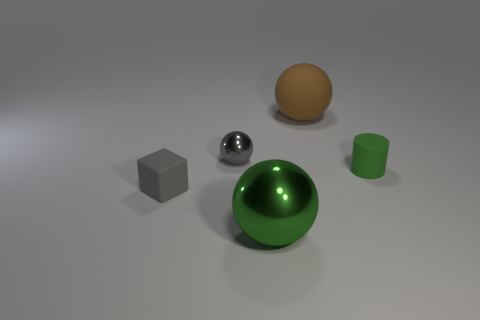Subtract all tiny balls. How many balls are left? 2 Add 2 green objects. How many objects exist? 7 Subtract all balls. How many objects are left? 2 Subtract all green balls. How many balls are left? 2 Subtract all small shiny things. Subtract all large shiny balls. How many objects are left? 3 Add 5 brown matte objects. How many brown matte objects are left? 6 Add 1 large purple metallic objects. How many large purple metallic objects exist? 1 Subtract 0 purple balls. How many objects are left? 5 Subtract all brown spheres. Subtract all green blocks. How many spheres are left? 2 Subtract all blue cylinders. How many gray spheres are left? 1 